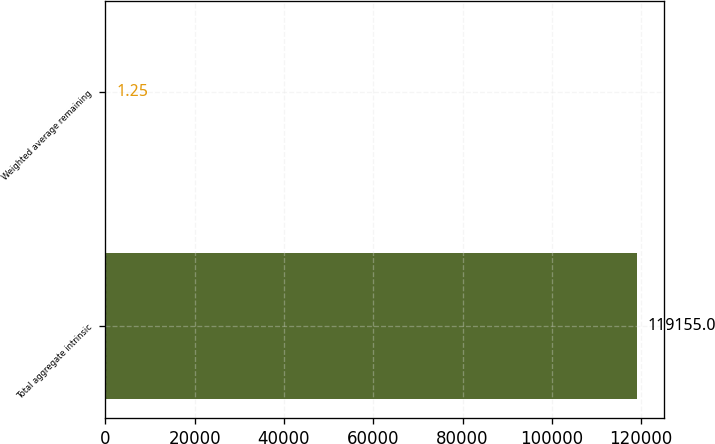<chart> <loc_0><loc_0><loc_500><loc_500><bar_chart><fcel>Total aggregate intrinsic<fcel>Weighted average remaining<nl><fcel>119155<fcel>1.25<nl></chart> 